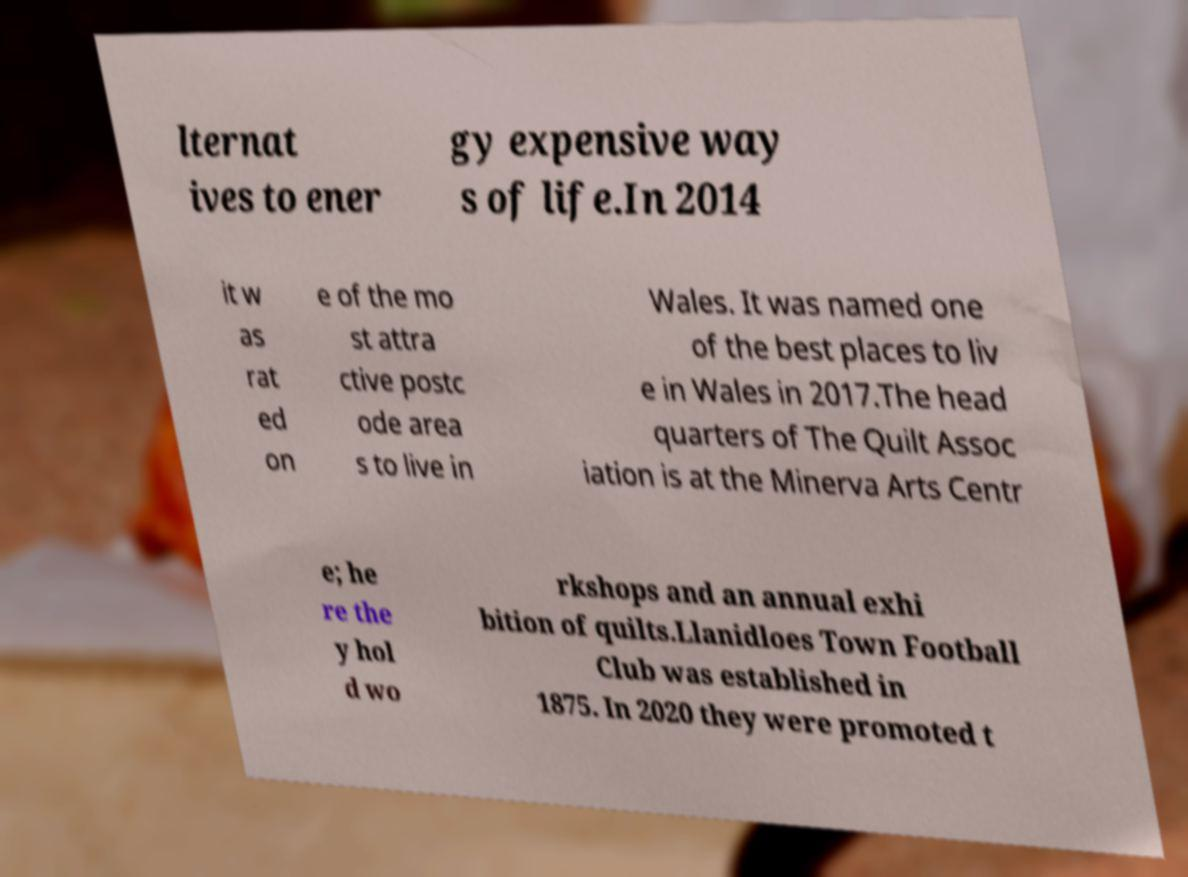There's text embedded in this image that I need extracted. Can you transcribe it verbatim? lternat ives to ener gy expensive way s of life.In 2014 it w as rat ed on e of the mo st attra ctive postc ode area s to live in Wales. It was named one of the best places to liv e in Wales in 2017.The head quarters of The Quilt Assoc iation is at the Minerva Arts Centr e; he re the y hol d wo rkshops and an annual exhi bition of quilts.Llanidloes Town Football Club was established in 1875. In 2020 they were promoted t 